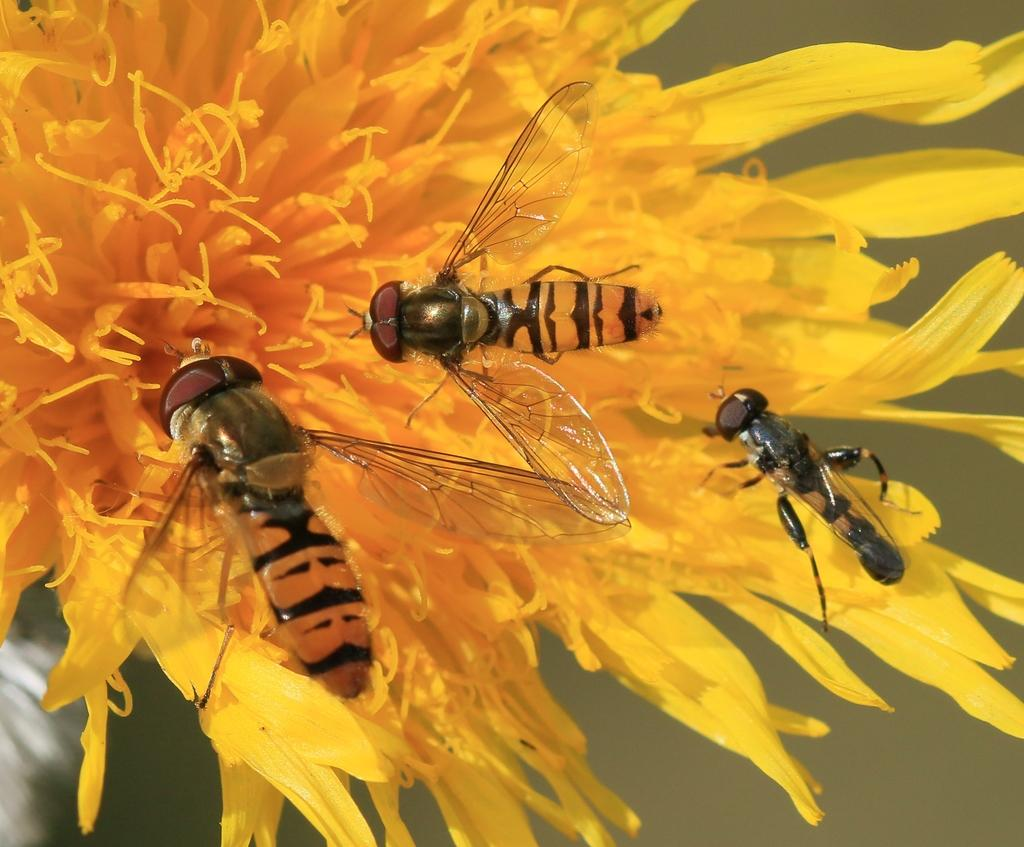What is the main subject of the image? There is a flower in the image. What color is the flower? The flower is yellow. Are there any other creatures or objects present on the flower? Yes, there are three flies on the flower. What type of committee is meeting near the flower in the image? There is no committee meeting near the flower in the image. Is there a gate visible in the image? No, there is no gate present in the image. 